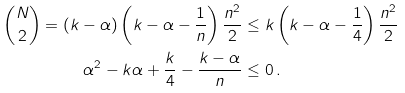Convert formula to latex. <formula><loc_0><loc_0><loc_500><loc_500>\binom { N } { 2 } = ( k - \alpha ) \left ( k - \alpha - \frac { 1 } { n } \right ) \frac { n ^ { 2 } } { 2 } & \leq k \left ( k - \alpha - \frac { 1 } { 4 } \right ) \frac { n ^ { 2 } } { 2 } \\ \alpha ^ { 2 } - k \alpha + \frac { k } { 4 } - \frac { k - \alpha } { n } & \leq 0 \, .</formula> 